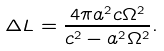<formula> <loc_0><loc_0><loc_500><loc_500>\Delta L = \frac { 4 \pi a ^ { 2 } c \Omega ^ { 2 } } { c ^ { 2 } - a ^ { 2 } \Omega ^ { 2 } } .</formula> 